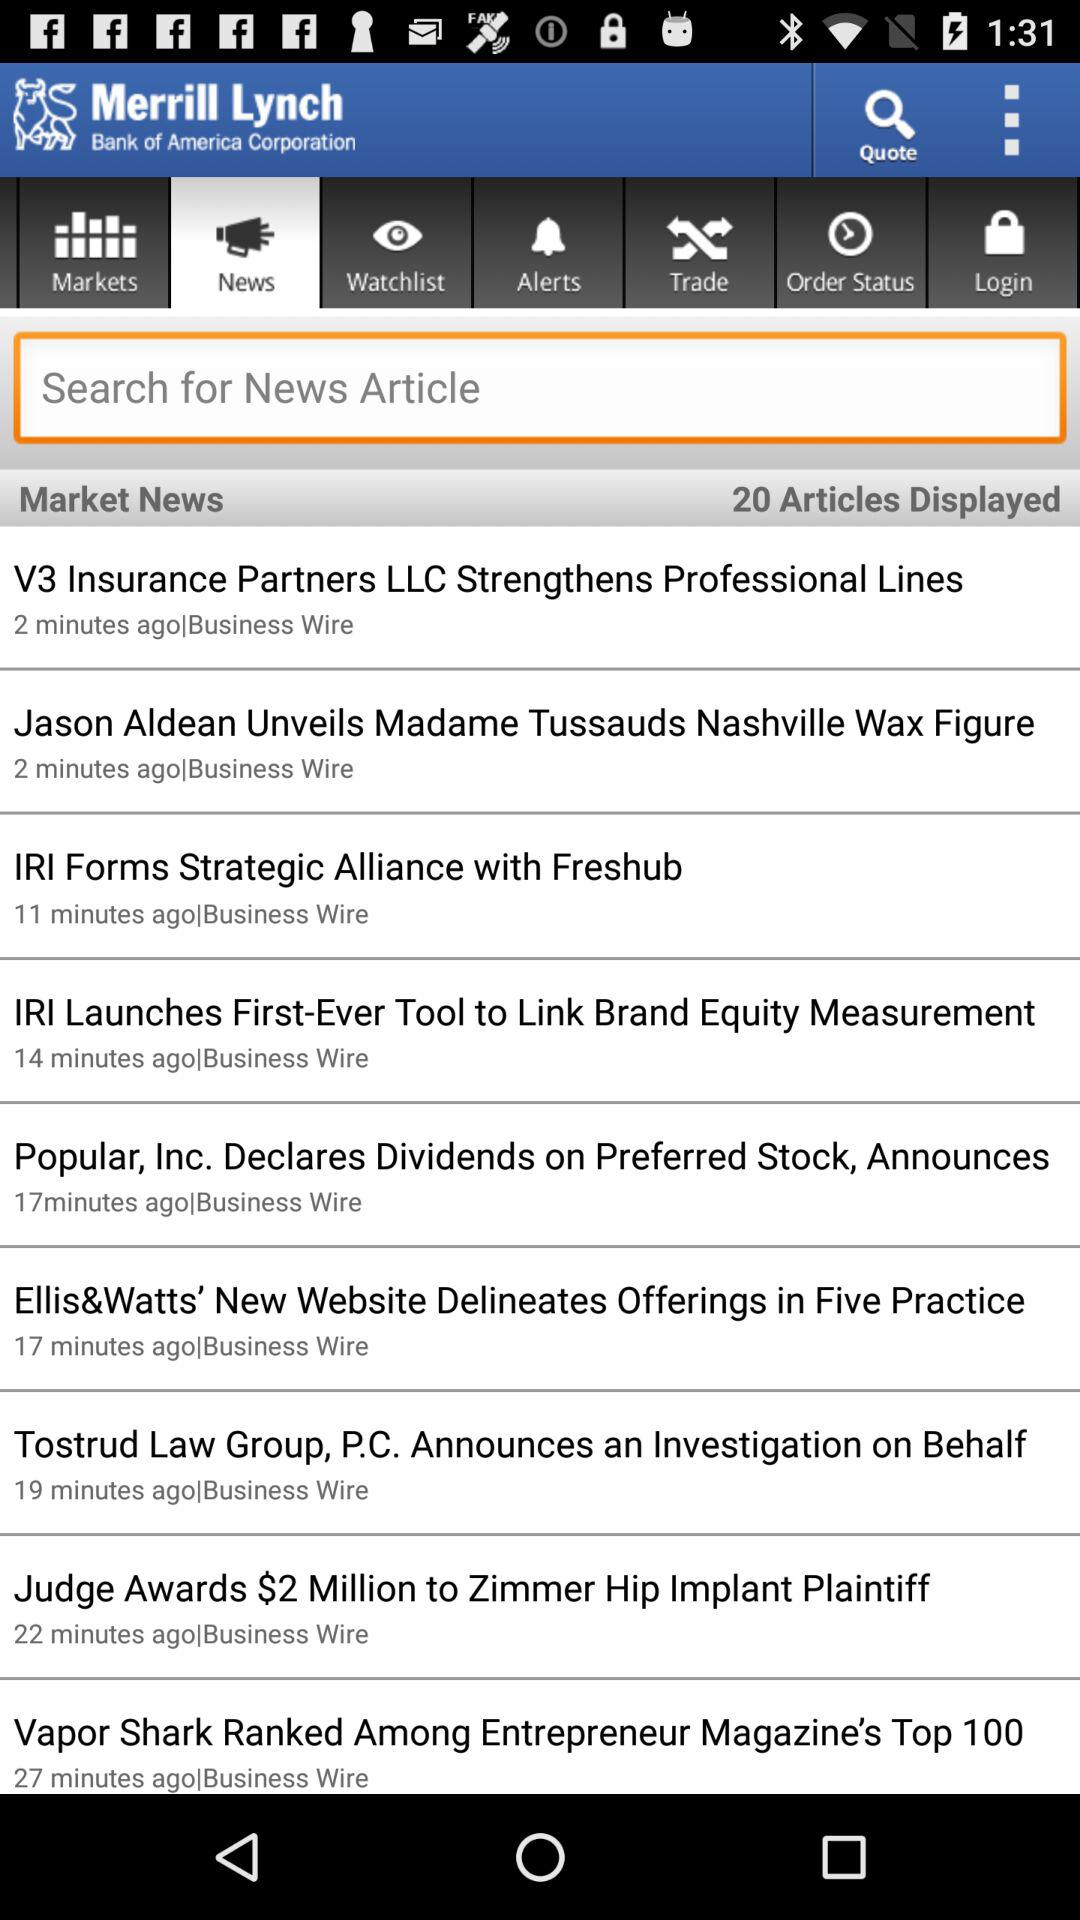When is the news about the "Tostrud Law Group, P.C. Announces an Investigation on Behalf" posted? The news is posted 19 minutes ago. 